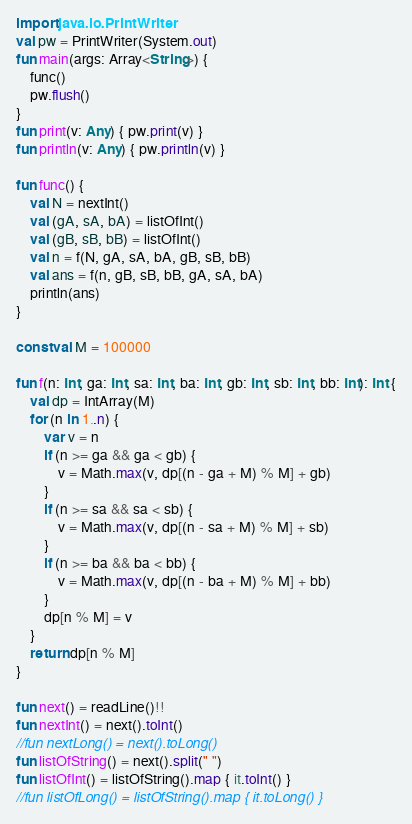<code> <loc_0><loc_0><loc_500><loc_500><_Kotlin_>import java.io.PrintWriter
val pw = PrintWriter(System.out)
fun main(args: Array<String>) {
    func()
    pw.flush()
}
fun print(v: Any) { pw.print(v) }
fun println(v: Any) { pw.println(v) }

fun func() {
    val N = nextInt()
    val (gA, sA, bA) = listOfInt()
    val (gB, sB, bB) = listOfInt()
    val n = f(N, gA, sA, bA, gB, sB, bB)
    val ans = f(n, gB, sB, bB, gA, sA, bA)
    println(ans)
}

const val M = 100000

fun f(n: Int, ga: Int, sa: Int, ba: Int, gb: Int, sb: Int, bb: Int): Int {
    val dp = IntArray(M)
    for (n in 1..n) {
        var v = n
        if (n >= ga && ga < gb) {
            v = Math.max(v, dp[(n - ga + M) % M] + gb)
        }
        if (n >= sa && sa < sb) {
            v = Math.max(v, dp[(n - sa + M) % M] + sb)
        }
        if (n >= ba && ba < bb) {
            v = Math.max(v, dp[(n - ba + M) % M] + bb)
        }
        dp[n % M] = v
    }
    return dp[n % M]
}

fun next() = readLine()!!
fun nextInt() = next().toInt()
//fun nextLong() = next().toLong()
fun listOfString() = next().split(" ")
fun listOfInt() = listOfString().map { it.toInt() }
//fun listOfLong() = listOfString().map { it.toLong() }
</code> 